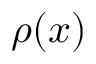Convert formula to latex. <formula><loc_0><loc_0><loc_500><loc_500>\rho ( x )</formula> 